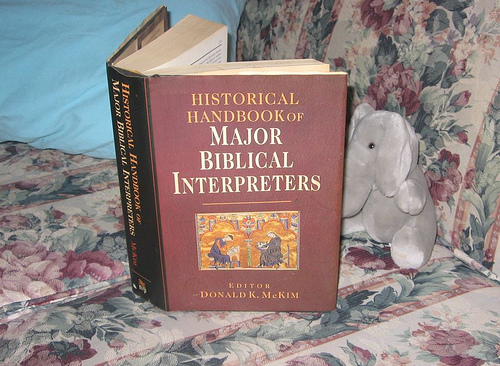<image>
Can you confirm if the book is on the sofa? Yes. Looking at the image, I can see the book is positioned on top of the sofa, with the sofa providing support. Where is the book in relation to the sofa? Is it in the sofa? No. The book is not contained within the sofa. These objects have a different spatial relationship. 